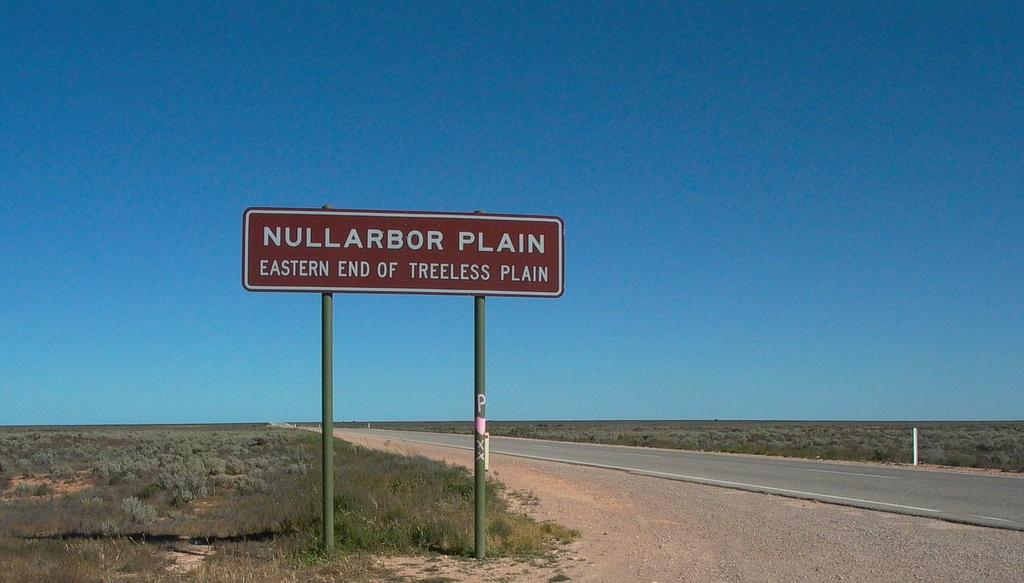<image>
Provide a brief description of the given image. A brown sign on a deserted country road that reads Nullarbor Plain. 